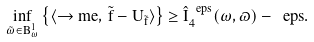Convert formula to latex. <formula><loc_0><loc_0><loc_500><loc_500>\inf _ { \tilde { \omega } \in B _ { \omega } ^ { 1 } } \left \{ \langle \to m e , \, \tilde { f } - U _ { \tilde { f } } \rangle \right \} \geq \hat { I } _ { 4 } ^ { \ e p s } ( \omega , \varpi ) - \ e p s .</formula> 